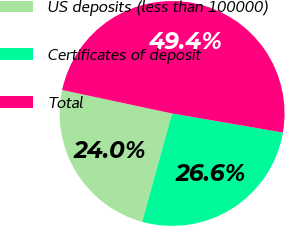Convert chart. <chart><loc_0><loc_0><loc_500><loc_500><pie_chart><fcel>US deposits (less than 100000)<fcel>Certificates of deposit<fcel>Total<nl><fcel>24.05%<fcel>26.58%<fcel>49.37%<nl></chart> 